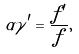<formula> <loc_0><loc_0><loc_500><loc_500>\alpha \gamma ^ { \prime } = \frac { f ^ { \prime } } { f } ,</formula> 